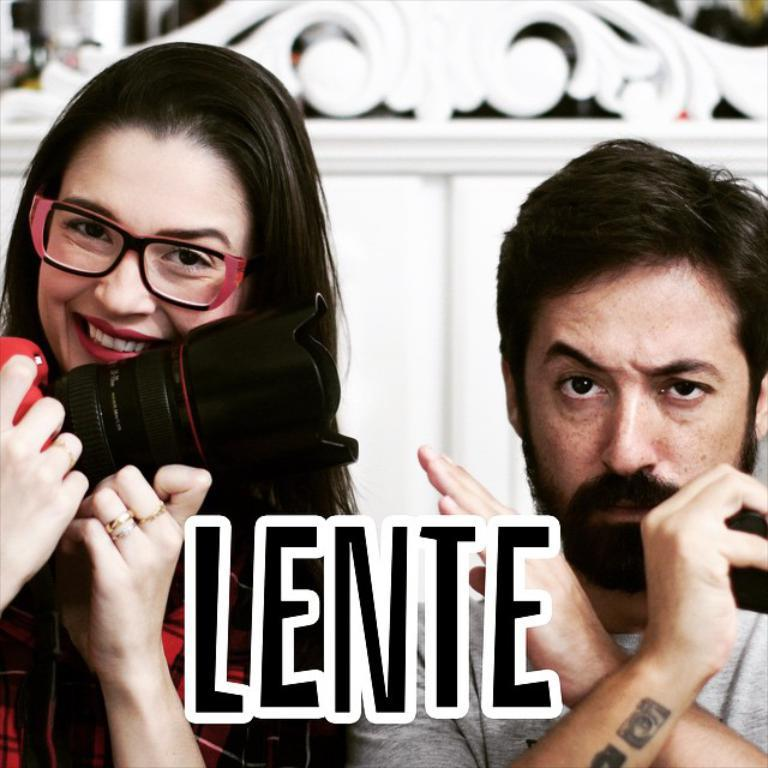How many people are in the image? There are two persons in the image. What is one of the persons doing in the image? One of the persons is holding a camera. Can you describe the appearance of the person holding the camera? The person holding the camera is wearing glasses. What is the facial expression of the person holding the camera? The person holding the camera is smiling. What type of music is the band playing in the background of the image? There is no band present in the image, so it is not possible to determine what type of music might be playing. 